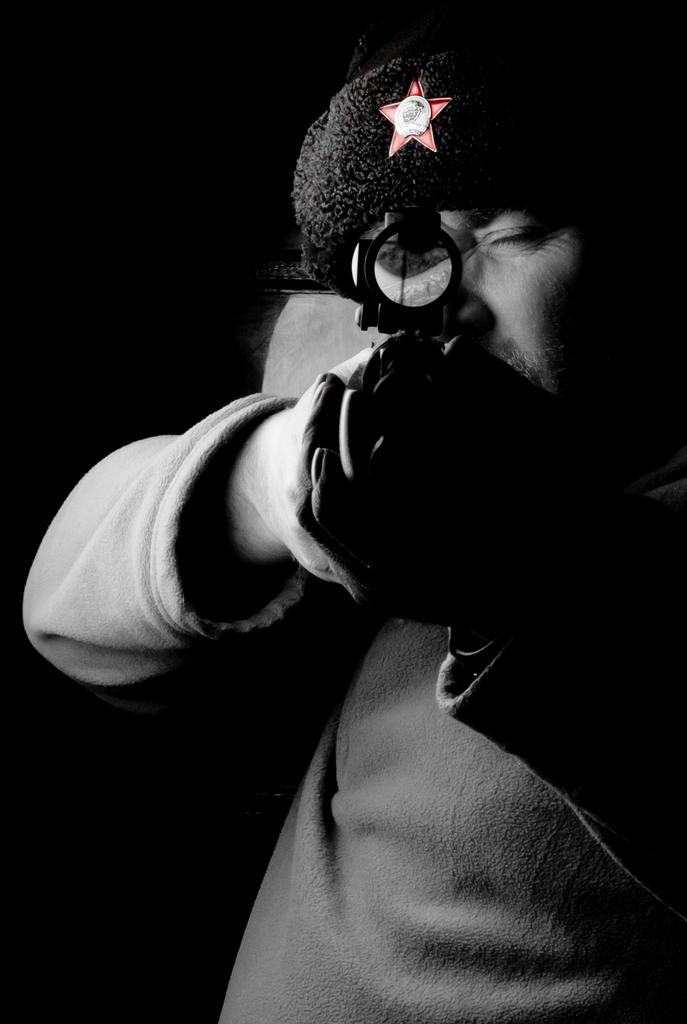Who is the main subject in the image? There is a person in the center of the image. What is the person wearing on their head? The person is wearing a cap. What is the person holding in their hands? The person is holding a gun. What type of summer clothing is the person wearing in the image? The provided facts do not mention any summer clothing; the person is wearing a cap. How does the person maintain their balance while holding the gun in the image? The provided facts do not mention any balance-related information; the person is simply holding the gun. 